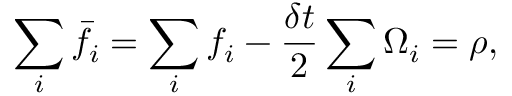Convert formula to latex. <formula><loc_0><loc_0><loc_500><loc_500>\sum _ { i } \bar { f } _ { i } = \sum _ { i } f _ { i } - \frac { \delta t } { 2 } \sum _ { i } \Omega _ { i } = \rho ,</formula> 